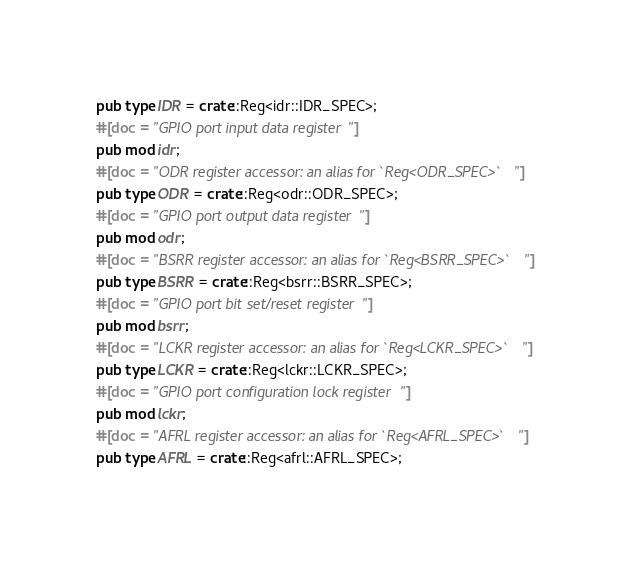Convert code to text. <code><loc_0><loc_0><loc_500><loc_500><_Rust_>pub type IDR = crate::Reg<idr::IDR_SPEC>;
#[doc = "GPIO port input data register"]
pub mod idr;
#[doc = "ODR register accessor: an alias for `Reg<ODR_SPEC>`"]
pub type ODR = crate::Reg<odr::ODR_SPEC>;
#[doc = "GPIO port output data register"]
pub mod odr;
#[doc = "BSRR register accessor: an alias for `Reg<BSRR_SPEC>`"]
pub type BSRR = crate::Reg<bsrr::BSRR_SPEC>;
#[doc = "GPIO port bit set/reset register"]
pub mod bsrr;
#[doc = "LCKR register accessor: an alias for `Reg<LCKR_SPEC>`"]
pub type LCKR = crate::Reg<lckr::LCKR_SPEC>;
#[doc = "GPIO port configuration lock register"]
pub mod lckr;
#[doc = "AFRL register accessor: an alias for `Reg<AFRL_SPEC>`"]
pub type AFRL = crate::Reg<afrl::AFRL_SPEC>;</code> 